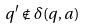Convert formula to latex. <formula><loc_0><loc_0><loc_500><loc_500>q ^ { \prime } \notin \delta ( q , a )</formula> 